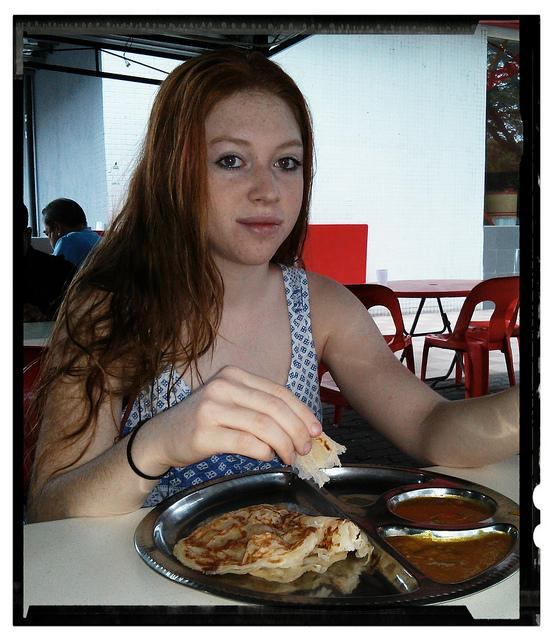What kind of bread is this?

Choices:
A) rye
B) white
C) naan
D) wheat naan 